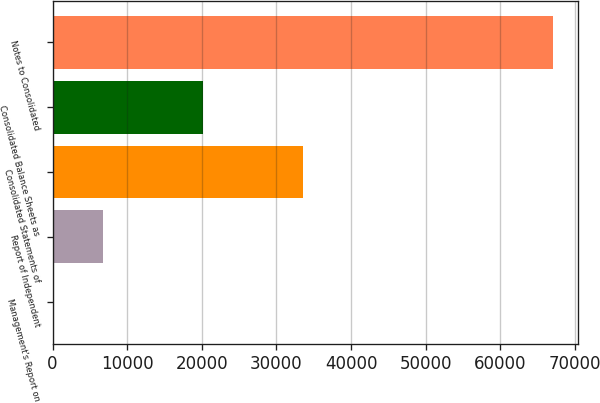Convert chart to OTSL. <chart><loc_0><loc_0><loc_500><loc_500><bar_chart><fcel>Management's Report on<fcel>Report of Independent<fcel>Consolidated Statements of<fcel>Consolidated Balance Sheets as<fcel>Notes to Consolidated<nl><fcel>59<fcel>6763.2<fcel>33580<fcel>20171.6<fcel>67101<nl></chart> 